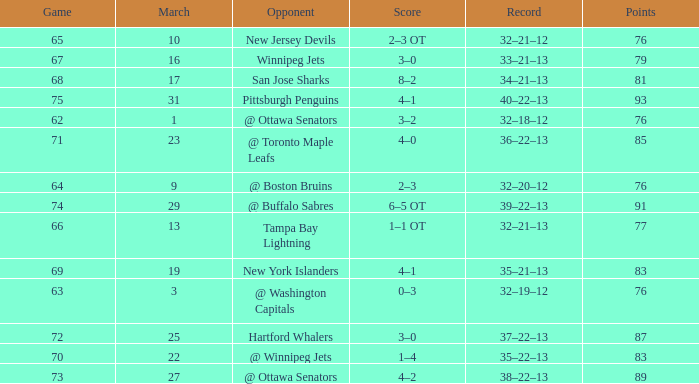How many games have a March of 19, and Points smaller than 83? 0.0. 